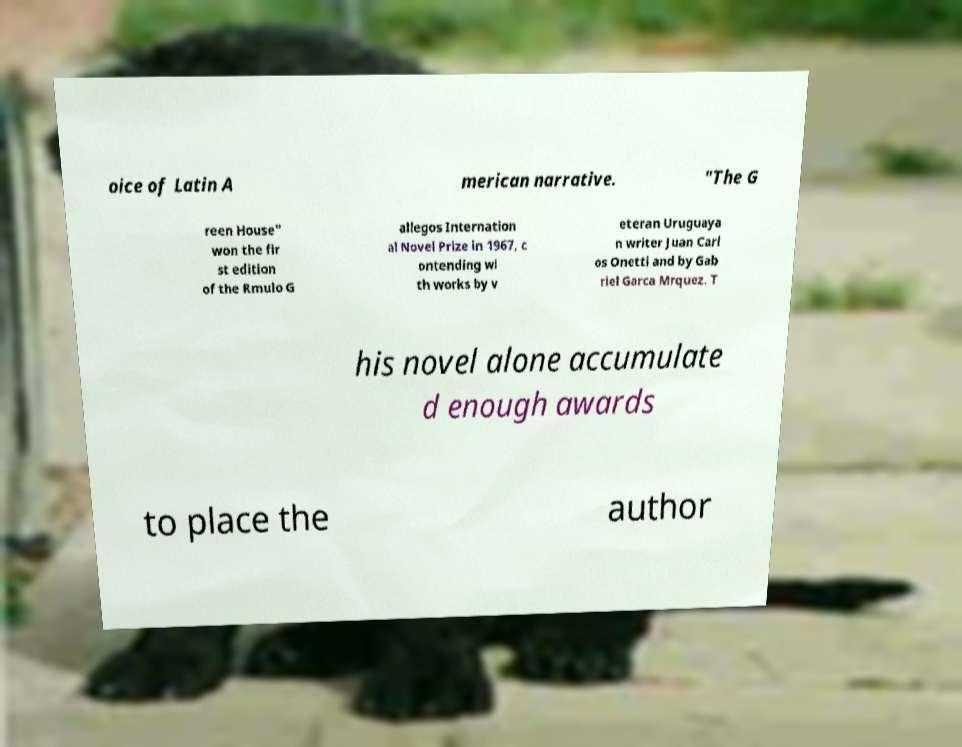Can you read and provide the text displayed in the image?This photo seems to have some interesting text. Can you extract and type it out for me? oice of Latin A merican narrative. "The G reen House" won the fir st edition of the Rmulo G allegos Internation al Novel Prize in 1967, c ontending wi th works by v eteran Uruguaya n writer Juan Carl os Onetti and by Gab riel Garca Mrquez. T his novel alone accumulate d enough awards to place the author 